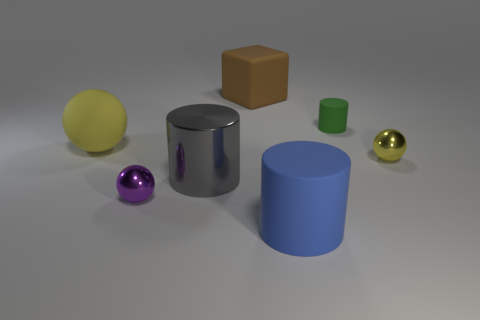Add 1 purple metallic balls. How many objects exist? 8 Subtract all blocks. How many objects are left? 6 Add 1 small metal balls. How many small metal balls are left? 3 Add 7 small green objects. How many small green objects exist? 8 Subtract 1 green cylinders. How many objects are left? 6 Subtract all small green matte cylinders. Subtract all matte objects. How many objects are left? 2 